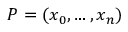<formula> <loc_0><loc_0><loc_500><loc_500>P = ( x _ { 0 } , \dots , x _ { n } ) \,</formula> 